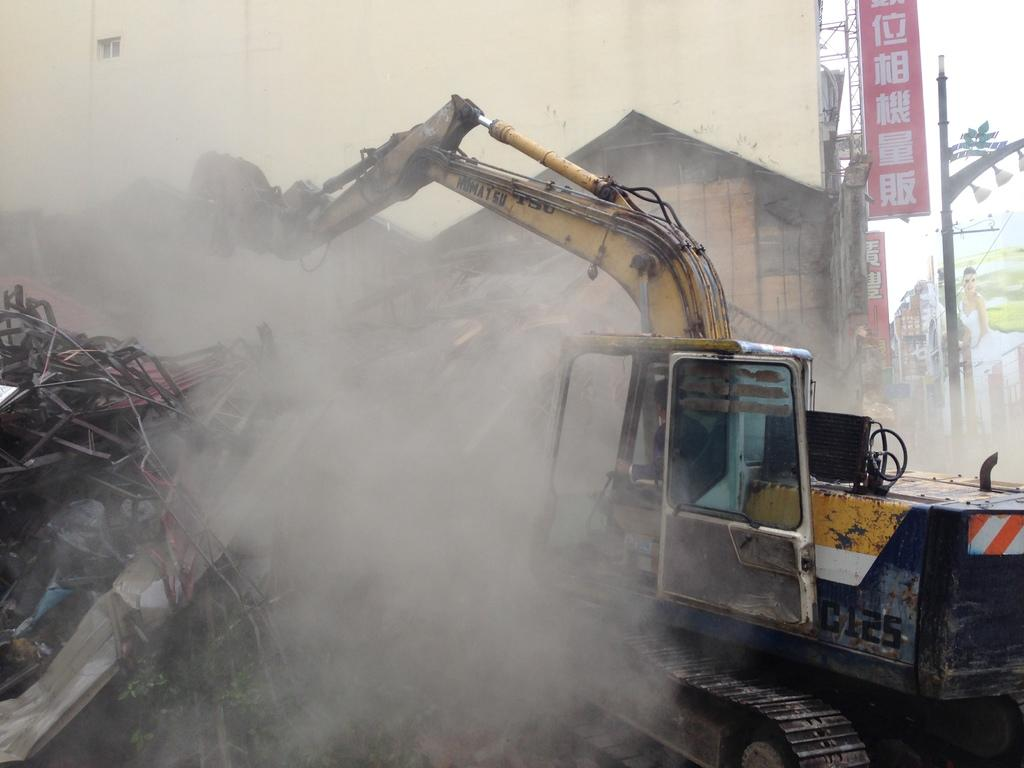What type of vehicle is in the image? There is a truck in the image. What type of building is in the image? There is a house in the image. What type of structure is in the image? There is a wall in the image. What can be seen coming from the truck in the image? There is smoke in the image. What type of signage is in the image? There are banners and a hoarding in the image. What type of vertical structures are in the image? There are poles in the image. What is visible in the background of the image? The sky is visible in the image. How many passengers are visible in the truck in the image? There is no information about passengers in the image, as it only shows a truck with smoke coming from it. What type of badge is being worn by the driver of the truck in the image? There is no driver or badge visible in the image; it only shows a truck with smoke coming from it. 